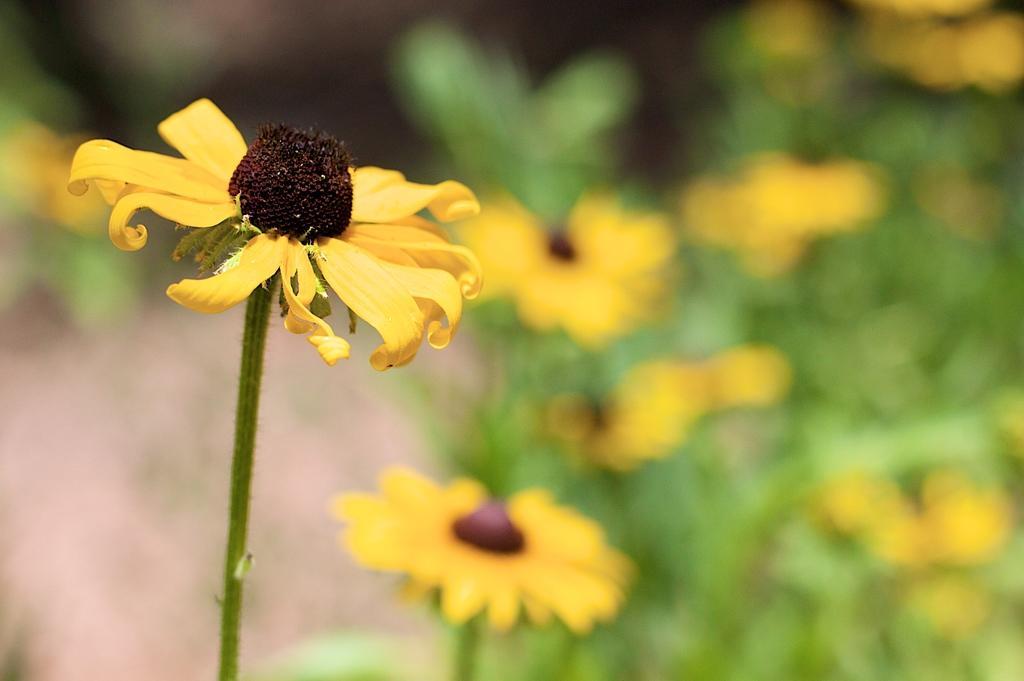Can you describe this image briefly? In this image, we can see a flower with stem. Background there is a blur view. Right side of the image, we can see so many plants with flowers. 